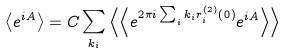<formula> <loc_0><loc_0><loc_500><loc_500>\left \langle e ^ { i A } \right \rangle = C \sum _ { k _ { i } } \left \langle \left \langle e ^ { 2 \pi i \sum _ { i } k _ { i } r _ { i } ^ { \left ( 2 \right ) } \left ( 0 \right ) } e ^ { i A } \right \rangle \right \rangle</formula> 